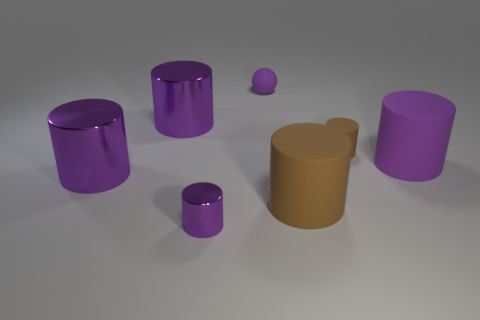Subtract all gray blocks. How many purple cylinders are left? 4 Subtract 2 cylinders. How many cylinders are left? 4 Subtract all brown cylinders. How many cylinders are left? 4 Subtract all brown cylinders. How many cylinders are left? 4 Subtract all green cylinders. Subtract all cyan blocks. How many cylinders are left? 6 Add 1 yellow metal cubes. How many objects exist? 8 Subtract all cylinders. How many objects are left? 1 Subtract 1 purple cylinders. How many objects are left? 6 Subtract all big cyan objects. Subtract all purple metallic cylinders. How many objects are left? 4 Add 6 purple rubber things. How many purple rubber things are left? 8 